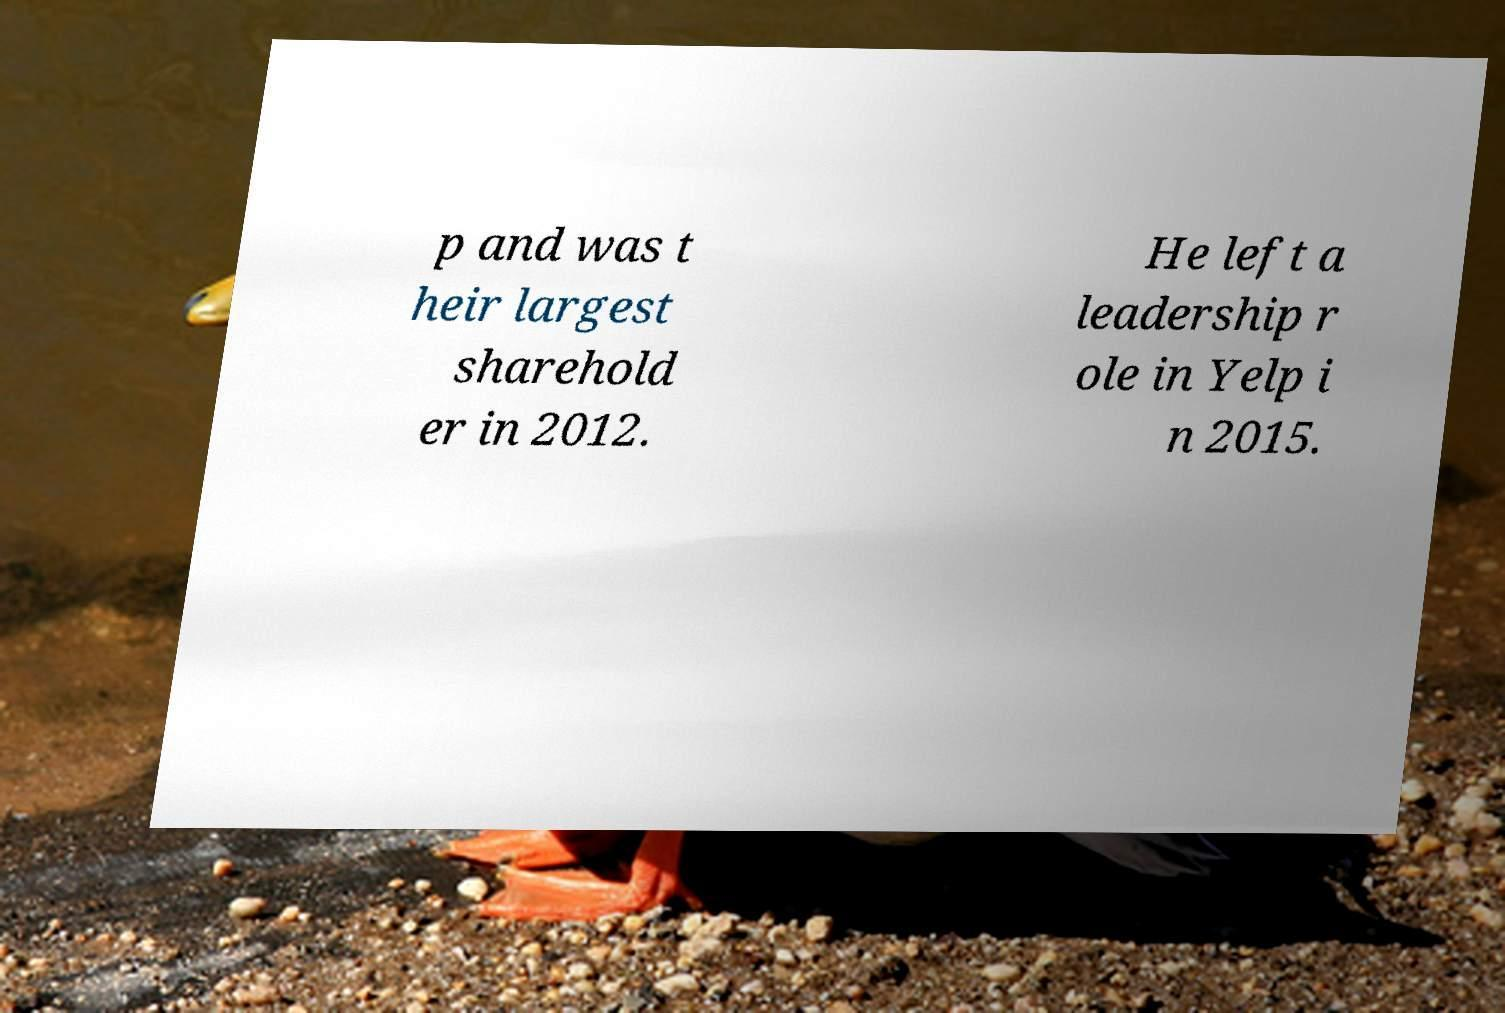Can you accurately transcribe the text from the provided image for me? p and was t heir largest sharehold er in 2012. He left a leadership r ole in Yelp i n 2015. 